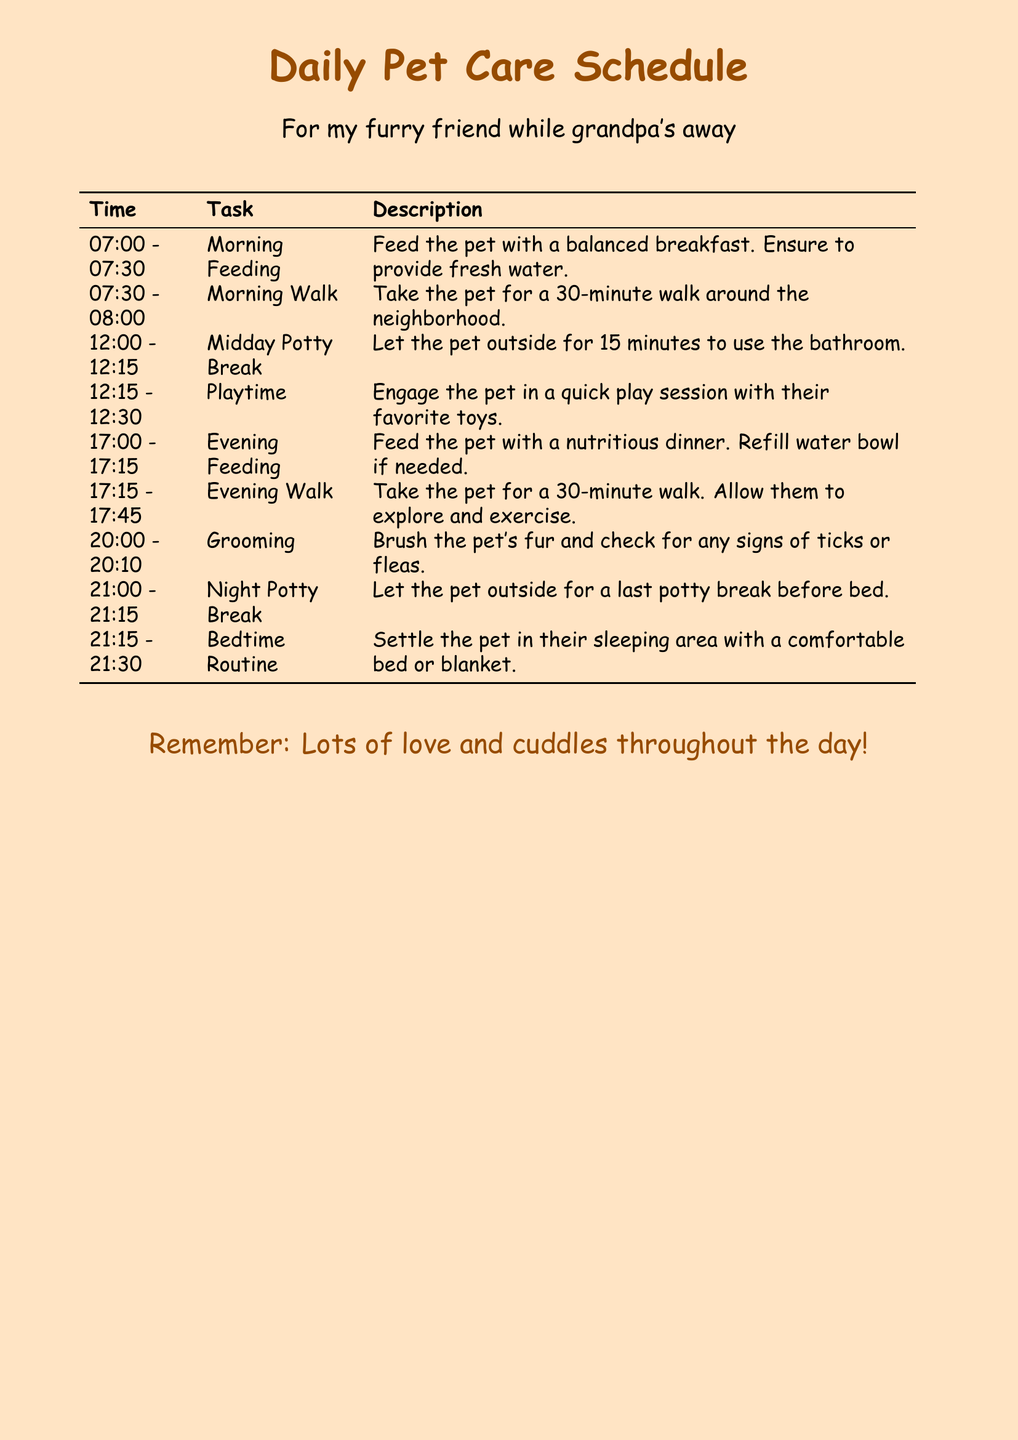What time is the morning feeding? The morning feeding starts at 07:00 and lasts until 07:30.
Answer: 07:00 - 07:30 How long is the evening walk? The document states the evening walk lasts for 30 minutes.
Answer: 30 minutes What task is scheduled immediately after the midday potty break? The task that follows the midday potty break is playtime from 12:15 to 12:30.
Answer: Playtime What activity is mentioned before bedtime? The last task before bedtime is the bedtime routine.
Answer: Bedtime routine How many tasks are listed in total? Counting each task in the document results in a total of 8 tasks.
Answer: 8 tasks What do you do during the grooming session? During the grooming session, you brush the pet's fur and check for signs of ticks or fleas.
Answer: Brush and check for ticks or fleas What is the overall theme of the document? The document is a checklist for caring for a pet while the owner is hospitalized.
Answer: Daily Pet Care Schedule What is the duration of the morning walk? The morning walk is scheduled for 30 minutes.
Answer: 30 minutes 